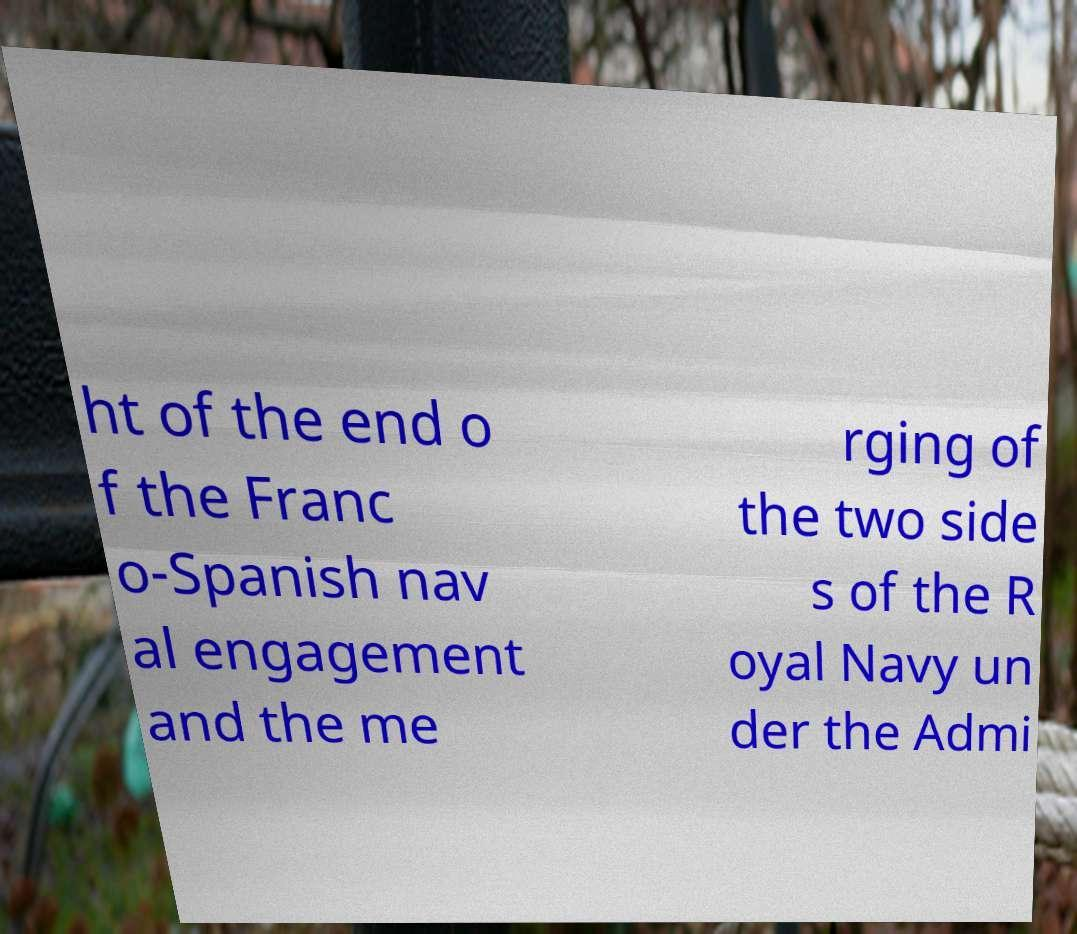I need the written content from this picture converted into text. Can you do that? ht of the end o f the Franc o-Spanish nav al engagement and the me rging of the two side s of the R oyal Navy un der the Admi 